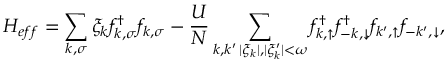Convert formula to latex. <formula><loc_0><loc_0><loc_500><loc_500>H _ { e f f } = \sum _ { k , \sigma } \xi _ { k } f _ { k , \sigma } ^ { \dag } f _ { k , \sigma } - \frac { U } { N } \sum _ { \substack { k , k ^ { \prime } \, | \xi _ { k } | , | \xi _ { k } ^ { \prime } | < \omega } } f _ { k , \uparrow } ^ { \dag } f _ { - k , \downarrow } ^ { \dag } f _ { k ^ { \prime } , \uparrow } f _ { - k ^ { \prime } , \downarrow } ,</formula> 